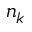<formula> <loc_0><loc_0><loc_500><loc_500>n _ { k }</formula> 